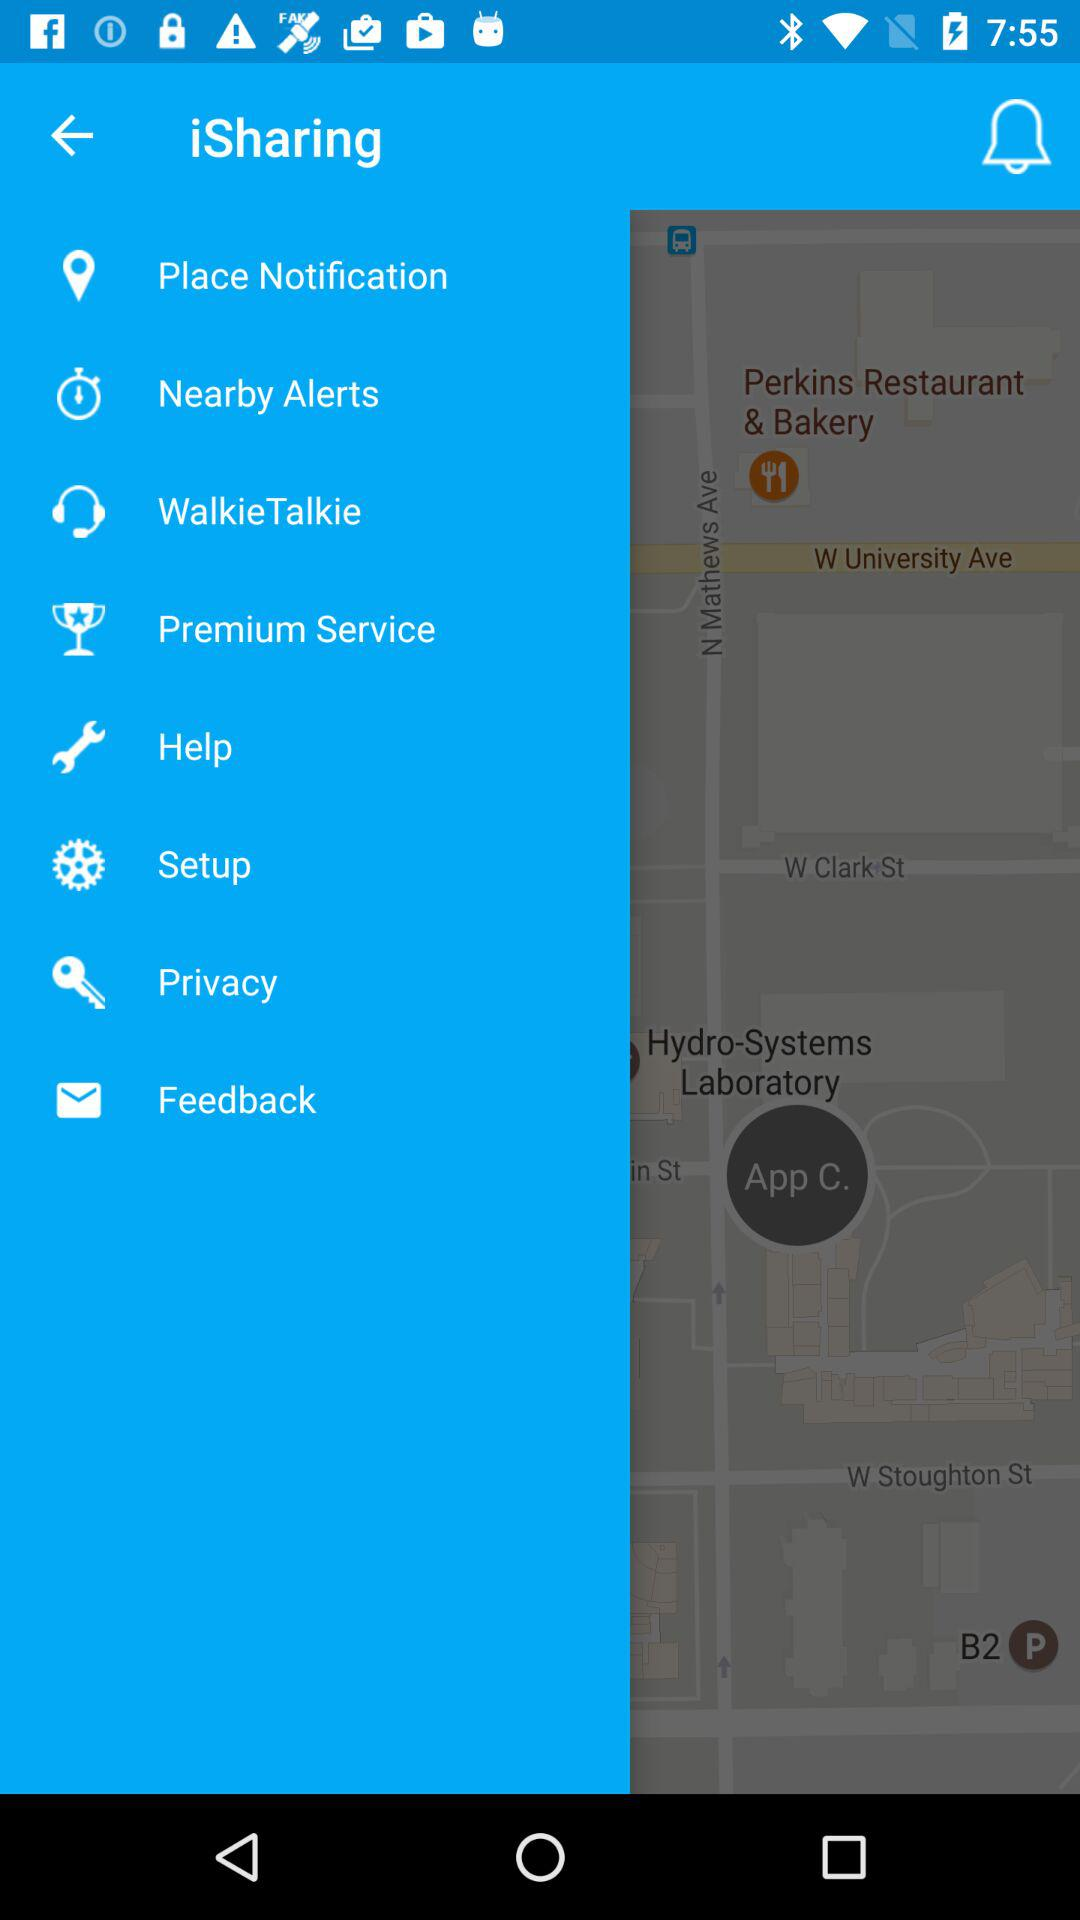What is the name of the application? The name of the application is "iSharing". 